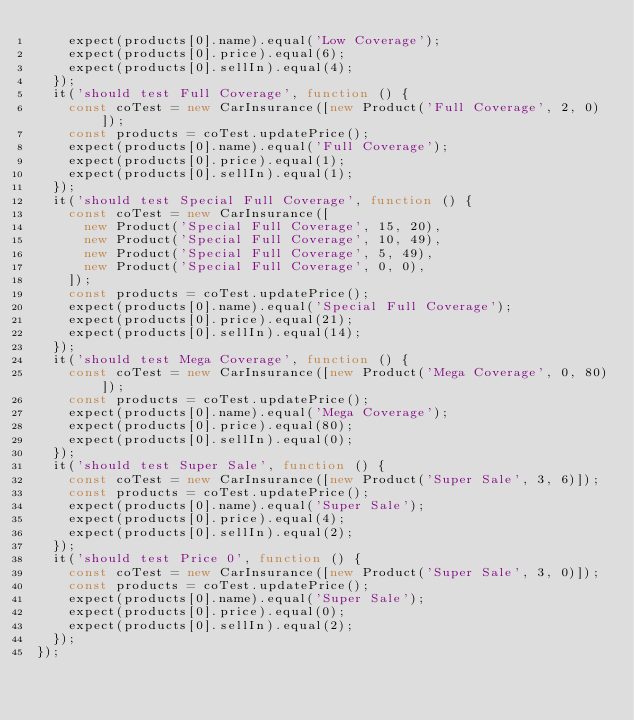Convert code to text. <code><loc_0><loc_0><loc_500><loc_500><_JavaScript_>    expect(products[0].name).equal('Low Coverage');
    expect(products[0].price).equal(6);
    expect(products[0].sellIn).equal(4);
  });
  it('should test Full Coverage', function () {
    const coTest = new CarInsurance([new Product('Full Coverage', 2, 0)]);
    const products = coTest.updatePrice();
    expect(products[0].name).equal('Full Coverage');
    expect(products[0].price).equal(1);
    expect(products[0].sellIn).equal(1);
  });
  it('should test Special Full Coverage', function () {
    const coTest = new CarInsurance([
      new Product('Special Full Coverage', 15, 20),
      new Product('Special Full Coverage', 10, 49),
      new Product('Special Full Coverage', 5, 49),
      new Product('Special Full Coverage', 0, 0),
    ]);
    const products = coTest.updatePrice();
    expect(products[0].name).equal('Special Full Coverage');
    expect(products[0].price).equal(21);
    expect(products[0].sellIn).equal(14);
  });
  it('should test Mega Coverage', function () {
    const coTest = new CarInsurance([new Product('Mega Coverage', 0, 80)]);
    const products = coTest.updatePrice();
    expect(products[0].name).equal('Mega Coverage');
    expect(products[0].price).equal(80);
    expect(products[0].sellIn).equal(0);
  });
  it('should test Super Sale', function () {
    const coTest = new CarInsurance([new Product('Super Sale', 3, 6)]);
    const products = coTest.updatePrice();
    expect(products[0].name).equal('Super Sale');
    expect(products[0].price).equal(4);
    expect(products[0].sellIn).equal(2);
  });
  it('should test Price 0', function () {
    const coTest = new CarInsurance([new Product('Super Sale', 3, 0)]);
    const products = coTest.updatePrice();
    expect(products[0].name).equal('Super Sale');
    expect(products[0].price).equal(0);
    expect(products[0].sellIn).equal(2);
  });
});
</code> 